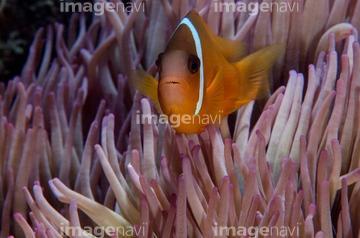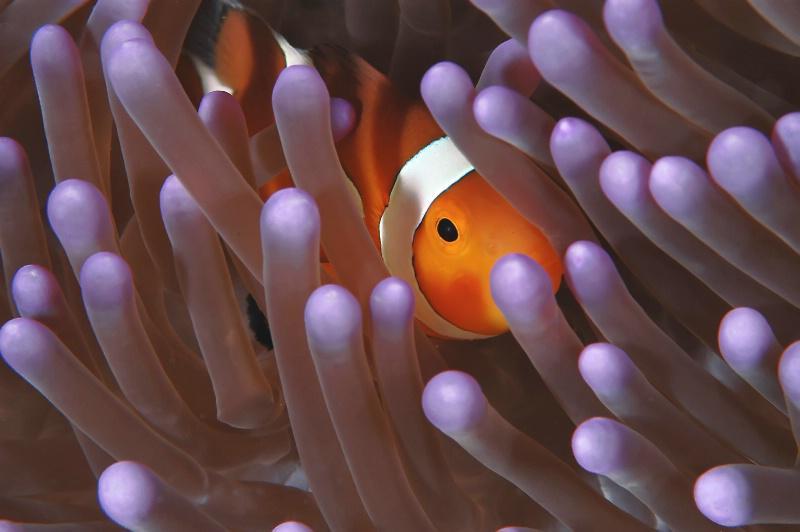The first image is the image on the left, the second image is the image on the right. Given the left and right images, does the statement "Left image shows an orange fish with one white stripe swimming among lavender-colored tendrils." hold true? Answer yes or no. Yes. 